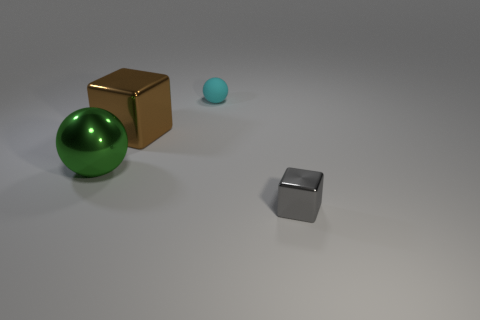Are there any gray matte blocks that have the same size as the brown metallic block?
Make the answer very short. No. There is a green metallic thing; is it the same shape as the big object right of the green thing?
Your answer should be compact. No. Is the size of the green metallic object behind the gray block the same as the cube that is behind the big green object?
Offer a very short reply. Yes. How many other things are the same shape as the small gray object?
Make the answer very short. 1. What material is the big thing to the left of the metallic block that is to the left of the tiny metallic cube?
Your response must be concise. Metal. How many matte objects are brown cylinders or small cyan balls?
Offer a terse response. 1. Is there any other thing that has the same material as the small block?
Your answer should be very brief. Yes. Are there any large things that are behind the thing to the left of the brown thing?
Offer a terse response. Yes. What number of things are spheres on the left side of the brown metallic cube or things behind the gray cube?
Make the answer very short. 3. Is there any other thing of the same color as the large cube?
Offer a terse response. No. 